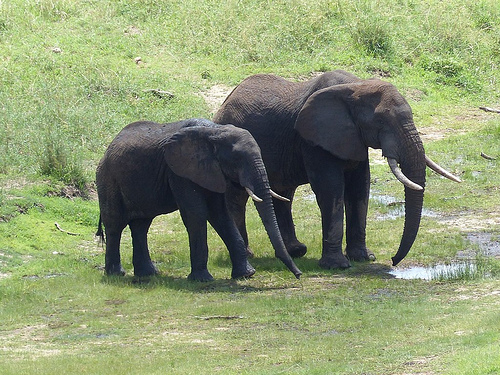What animal is drinking from a puddle? An elephant is drinking from a puddle in this image. 